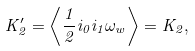Convert formula to latex. <formula><loc_0><loc_0><loc_500><loc_500>K ^ { \prime } _ { 2 } = \left \langle \frac { 1 } { 2 } i _ { 0 } i _ { 1 } \omega _ { w } \right \rangle = K _ { 2 } ,</formula> 